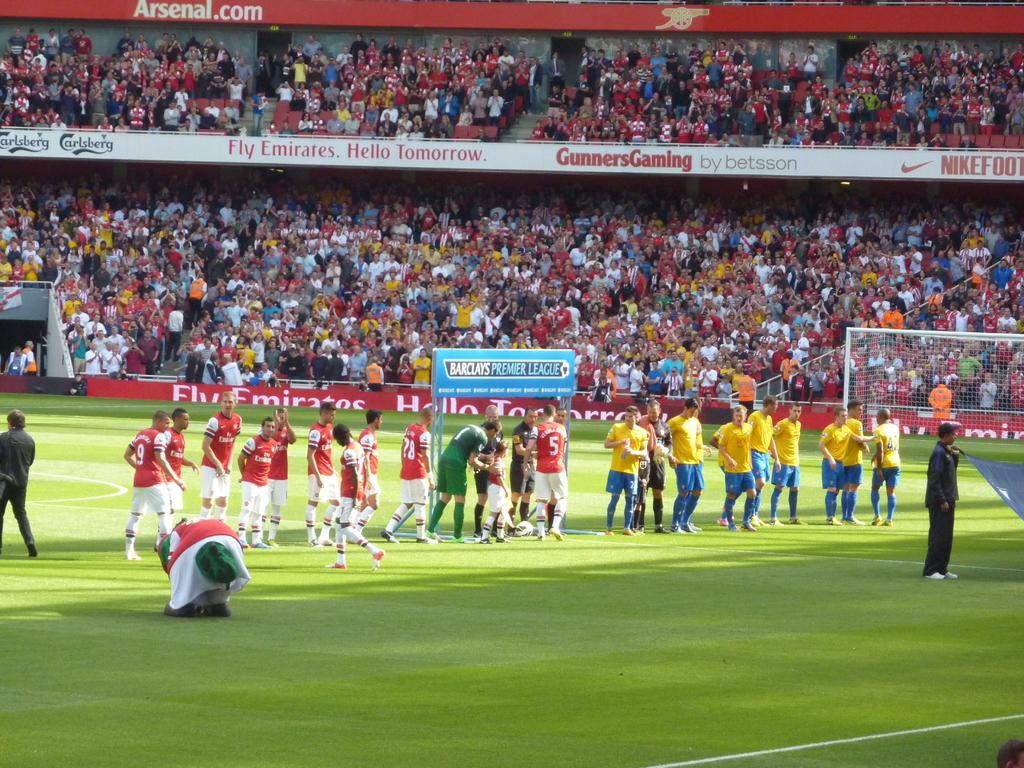Provide a one-sentence caption for the provided image. The professional soccer league is being sponsored by Barclays and Emirates. 